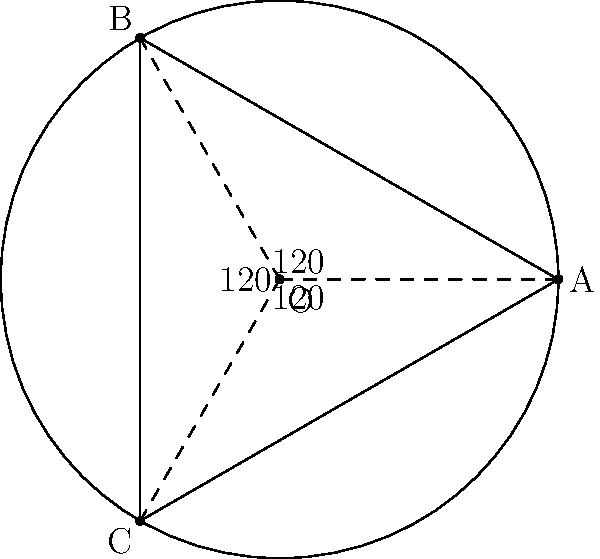In a circular waiting area with a radius of 10 meters, you want to implement an efficient queue system with three entry points. If the entry points are equally spaced around the circumference, what is the straight-line distance between any two adjacent entry points? Round your answer to the nearest tenth of a meter. To solve this problem, let's follow these steps:

1) The entry points form an equilateral triangle inscribed in the circle. The center of the circle is at the center of this triangle.

2) In an equilateral triangle, the angle between any two sides at the center is 360° ÷ 3 = 120°.

3) We can split this equilateral triangle into six congruent right triangles. Let's focus on one of these right triangles.

4) In this right triangle:
   - The hypotenuse is the radius of the circle (10 meters)
   - The angle at the center is 60° (half of 120°)

5) We need to find the side opposite to the 60° angle, which is half the distance between two entry points.

6) In a 30-60-90 triangle, the side opposite to the 60° angle is $\frac{\sqrt{3}}{2}$ times the hypotenuse.

7) So, half the distance we're looking for is:

   $$\frac{\sqrt{3}}{2} \times 10 = 5\sqrt{3}$$

8) The full distance is twice this:

   $$2 \times 5\sqrt{3} = 10\sqrt{3}$$

9) $10\sqrt{3} \approx 17.32$ meters

10) Rounding to the nearest tenth: 17.3 meters
Answer: 17.3 meters 